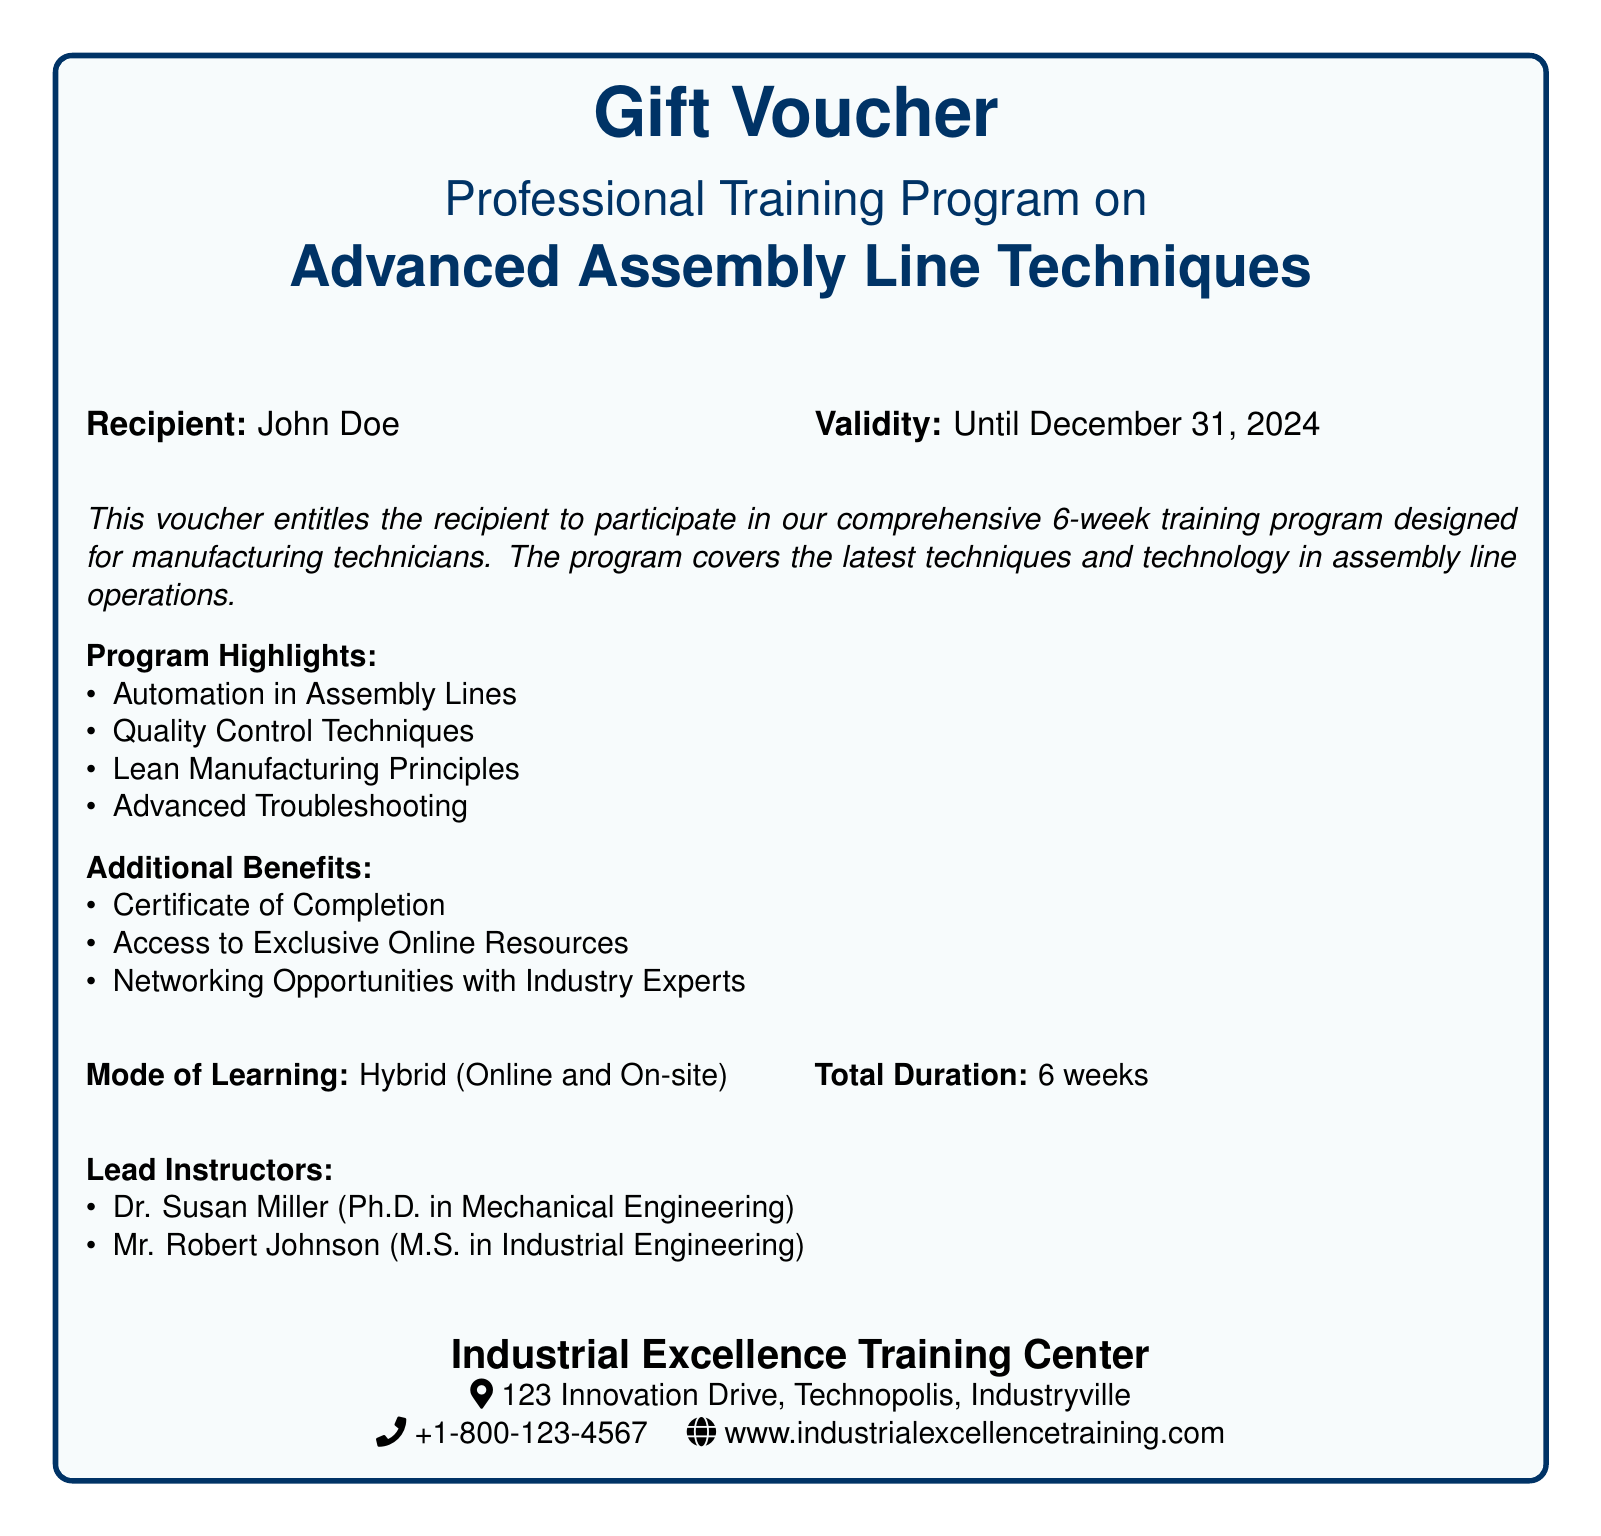What is the name of the recipient? The document specifies "John Doe" as the recipient of the voucher.
Answer: John Doe What is the validity date of the voucher? The voucher is valid until December 31, 2024, as stated in the document.
Answer: December 31, 2024 What is the total duration of the training program? The document mentions that the program lasts for a total of 6 weeks.
Answer: 6 weeks Who are the lead instructors for the program? The document lists Dr. Susan Miller and Mr. Robert Johnson as the lead instructors.
Answer: Dr. Susan Miller, Mr. Robert Johnson What mode of learning is offered for the program? The document indicates that the mode of learning is Hybrid (Online and On-site).
Answer: Hybrid (Online and On-site) What is one of the program highlights? The document provides several highlights, one of which is Automation in Assembly Lines.
Answer: Automation in Assembly Lines What type of certificate will participants receive? The document states that participants will receive a Certificate of Completion.
Answer: Certificate of Completion What is the address of the Industrial Excellence Training Center? The document lists the address as 123 Innovation Drive, Technopolis, Industryville.
Answer: 123 Innovation Drive, Technopolis, Industryville 